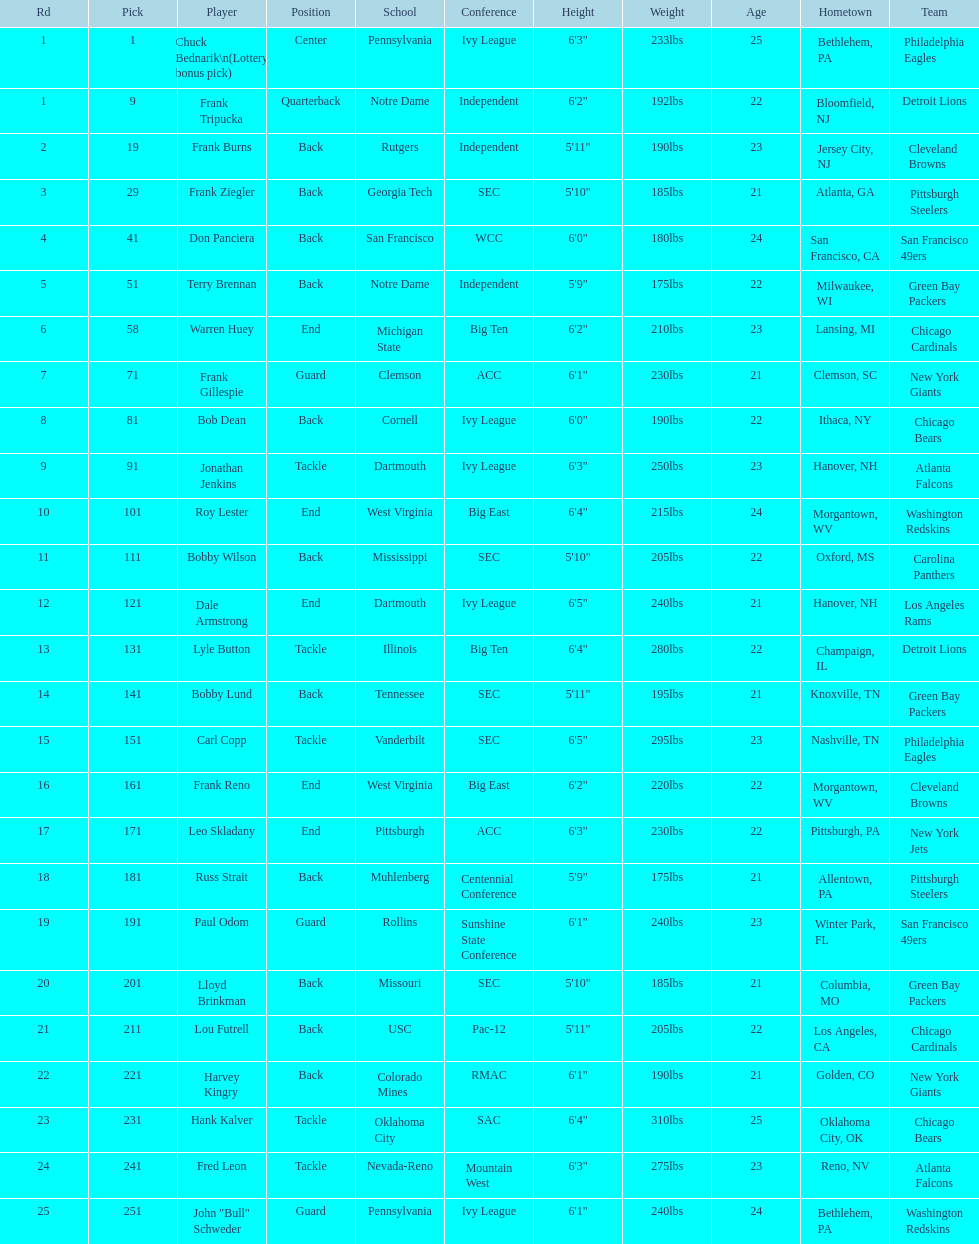Help me parse the entirety of this table. {'header': ['Rd', 'Pick', 'Player', 'Position', 'School', 'Conference', 'Height', 'Weight', 'Age', 'Hometown', 'Team'], 'rows': [['1', '1', 'Chuck Bednarik\\n(Lottery bonus pick)', 'Center', 'Pennsylvania', 'Ivy League', '6\'3"', '233lbs', '25', 'Bethlehem, PA', 'Philadelphia Eagles'], ['1', '9', 'Frank Tripucka', 'Quarterback', 'Notre Dame', 'Independent', '6\'2"', '192lbs', '22', 'Bloomfield, NJ', 'Detroit Lions'], ['2', '19', 'Frank Burns', 'Back', 'Rutgers', 'Independent', '5\'11"', '190lbs', '23', 'Jersey City, NJ', 'Cleveland  Browns'], ['3', '29', 'Frank Ziegler', 'Back', 'Georgia Tech', 'SEC', '5\'10"', '185lbs', '21', 'Atlanta, GA', 'Pittsburgh Steelers'], ['4', '41', 'Don Panciera', 'Back', 'San Francisco', 'WCC', '6\'0"', '180lbs', '24', 'San Francisco, CA', 'San Francisco 49ers'], ['5', '51', 'Terry Brennan', 'Back', 'Notre Dame', 'Independent', '5\'9"', '175lbs', '22', 'Milwaukee, WI', 'Green Bay Packers'], ['6', '58', 'Warren Huey', 'End', 'Michigan State', 'Big Ten', '6\'2"', '210lbs', '23', 'Lansing, MI', 'Chicago Cardinals'], ['7', '71', 'Frank Gillespie', 'Guard', 'Clemson', 'ACC', '6\'1"', '230lbs', '21', 'Clemson, SC', 'New York Giants'], ['8', '81', 'Bob Dean', 'Back', 'Cornell', 'Ivy League', '6\'0"', '190lbs', '22', 'Ithaca, NY', 'Chicago Bears'], ['9', '91', 'Jonathan Jenkins', 'Tackle', 'Dartmouth', 'Ivy League', '6\'3"', '250lbs', '23', 'Hanover, NH', 'Atlanta Falcons'], ['10', '101', 'Roy Lester', 'End', 'West Virginia', 'Big East', '6\'4"', '215lbs', '24', 'Morgantown, WV', 'Washington Redskins'], ['11', '111', 'Bobby Wilson', 'Back', 'Mississippi', 'SEC', '5\'10"', '205lbs', '22', 'Oxford, MS', 'Carolina Panthers'], ['12', '121', 'Dale Armstrong', 'End', 'Dartmouth', 'Ivy League', '6\'5"', '240lbs', '21', 'Hanover, NH', 'Los Angeles Rams'], ['13', '131', 'Lyle Button', 'Tackle', 'Illinois', 'Big Ten', '6\'4"', '280lbs', '22', 'Champaign, IL', 'Detroit Lions'], ['14', '141', 'Bobby Lund', 'Back', 'Tennessee', 'SEC', '5\'11"', '195lbs', '21', 'Knoxville, TN', 'Green Bay Packers'], ['15', '151', 'Carl Copp', 'Tackle', 'Vanderbilt', 'SEC', '6\'5"', '295lbs', '23', 'Nashville, TN', 'Philadelphia Eagles'], ['16', '161', 'Frank Reno', 'End', 'West Virginia', 'Big East', '6\'2"', '220lbs', '22', 'Morgantown, WV', 'Cleveland Browns'], ['17', '171', 'Leo Skladany', 'End', 'Pittsburgh', 'ACC', '6\'3"', '230lbs', '22', 'Pittsburgh, PA', 'New York Jets'], ['18', '181', 'Russ Strait', 'Back', 'Muhlenberg', 'Centennial Conference', '5\'9"', '175lbs', '21', 'Allentown, PA', 'Pittsburgh Steelers'], ['19', '191', 'Paul Odom', 'Guard', 'Rollins', 'Sunshine State Conference', '6\'1"', '240lbs', '23', 'Winter Park, FL', 'San Francisco 49ers'], ['20', '201', 'Lloyd Brinkman', 'Back', 'Missouri', 'SEC', '5\'10"', '185lbs', '21', 'Columbia, MO', 'Green Bay Packers'], ['21', '211', 'Lou Futrell', 'Back', 'USC', 'Pac-12', '5\'11"', '205lbs', '22', 'Los Angeles, CA', 'Chicago Cardinals'], ['22', '221', 'Harvey Kingry', 'Back', 'Colorado Mines', 'RMAC', '6\'1"', '190lbs', '21', 'Golden, CO', 'New York Giants'], ['23', '231', 'Hank Kalver', 'Tackle', 'Oklahoma City', 'SAC', '6\'4"', '310lbs', '25', 'Oklahoma City, OK', 'Chicago Bears'], ['24', '241', 'Fred Leon', 'Tackle', 'Nevada-Reno', 'Mountain West', '6\'3"', '275lbs', '23', 'Reno, NV', 'Atlanta Falcons'], ['25', '251', 'John "Bull" Schweder', 'Guard', 'Pennsylvania', 'Ivy League', '6\'1"', '240lbs', '24', 'Bethlehem, PA', 'Washington Redskins']]} How many draft picks were between frank tripucka and dale armstrong? 10. 